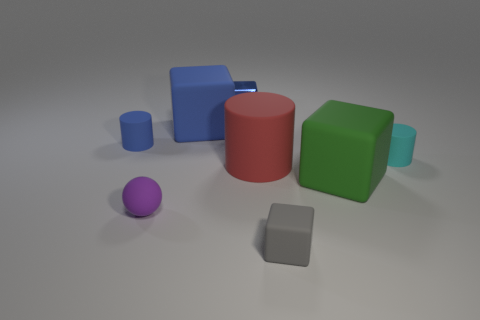Subtract 1 blocks. How many blocks are left? 3 Subtract all purple blocks. Subtract all blue cylinders. How many blocks are left? 4 Add 1 brown metallic things. How many objects exist? 9 Subtract all cylinders. How many objects are left? 5 Subtract 0 yellow spheres. How many objects are left? 8 Subtract all large red rubber cylinders. Subtract all purple rubber things. How many objects are left? 6 Add 4 red matte things. How many red matte things are left? 5 Add 8 small blue cylinders. How many small blue cylinders exist? 9 